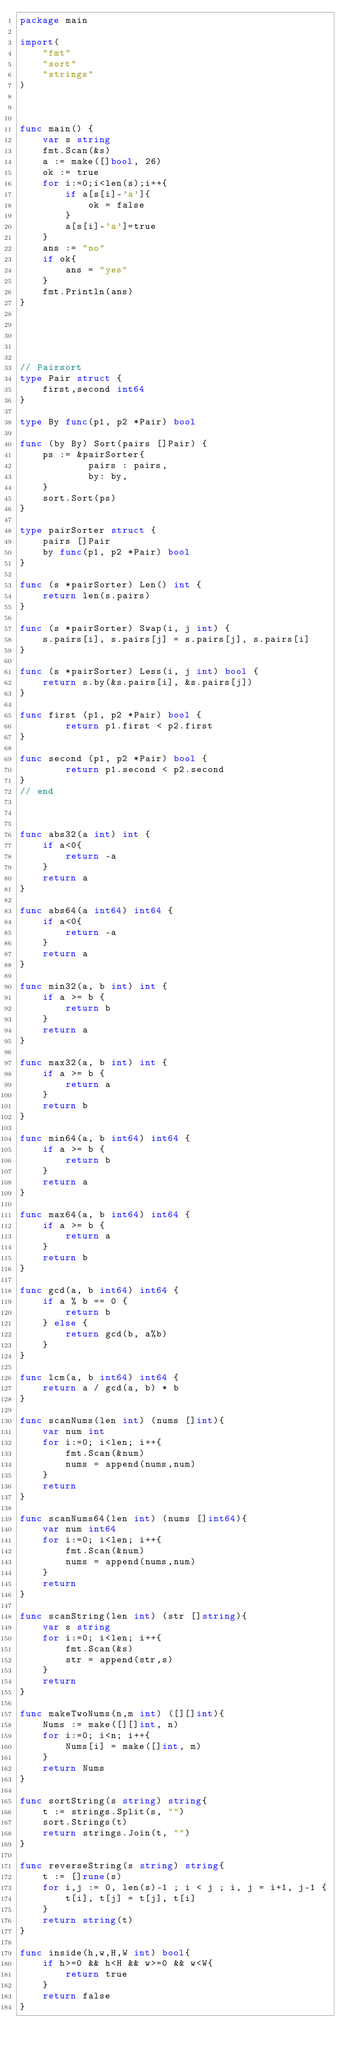<code> <loc_0><loc_0><loc_500><loc_500><_Go_>package main

import(
    "fmt"
    "sort"
    "strings"
)



func main() {
    var s string
    fmt.Scan(&s)
    a := make([]bool, 26)
    ok := true
    for i:=0;i<len(s);i++{
        if a[s[i]-'a']{
            ok = false
        }
        a[s[i]-'a']=true
    }
    ans := "no"
    if ok{
        ans = "yes"
    }
    fmt.Println(ans)
}





// Pairsort
type Pair struct {
    first,second int64
}

type By func(p1, p2 *Pair) bool

func (by By) Sort(pairs []Pair) {
    ps := &pairSorter{
            pairs : pairs,
            by: by,
    }
    sort.Sort(ps)
}

type pairSorter struct {
    pairs []Pair
    by func(p1, p2 *Pair) bool
}

func (s *pairSorter) Len() int {
    return len(s.pairs)
}

func (s *pairSorter) Swap(i, j int) {
    s.pairs[i], s.pairs[j] = s.pairs[j], s.pairs[i]
}

func (s *pairSorter) Less(i, j int) bool {
    return s.by(&s.pairs[i], &s.pairs[j])
}

func first (p1, p2 *Pair) bool {
        return p1.first < p2.first
}

func second (p1, p2 *Pair) bool {
        return p1.second < p2.second
}
// end



func abs32(a int) int {
    if a<0{
        return -a
    }
    return a
}

func abs64(a int64) int64 {
    if a<0{
        return -a
    }
    return a
}

func min32(a, b int) int {
    if a >= b {
        return b
    }
    return a
}

func max32(a, b int) int {
    if a >= b {
        return a
    }
    return b
}

func min64(a, b int64) int64 {
    if a >= b {
        return b
    }
    return a
}

func max64(a, b int64) int64 {
    if a >= b {
        return a
    }
    return b
}

func gcd(a, b int64) int64 {
    if a % b == 0 {
        return b
    } else {
        return gcd(b, a%b)
    }
}

func lcm(a, b int64) int64 {
    return a / gcd(a, b) * b
}

func scanNums(len int) (nums []int){
    var num int
    for i:=0; i<len; i++{
        fmt.Scan(&num)
        nums = append(nums,num)
    }
    return
}

func scanNums64(len int) (nums []int64){
    var num int64
    for i:=0; i<len; i++{
        fmt.Scan(&num)
        nums = append(nums,num)
    }
    return
}

func scanString(len int) (str []string){
    var s string
    for i:=0; i<len; i++{
        fmt.Scan(&s)
        str = append(str,s)
    }
    return
}

func makeTwoNums(n,m int) ([][]int){
    Nums := make([][]int, n)
    for i:=0; i<n; i++{
        Nums[i] = make([]int, m)
    }
    return Nums
}

func sortString(s string) string{
    t := strings.Split(s, "")
    sort.Strings(t)
    return strings.Join(t, "")
}

func reverseString(s string) string{
    t := []rune(s)
    for i,j := 0, len(s)-1 ; i < j ; i, j = i+1, j-1 {
        t[i], t[j] = t[j], t[i]
    }
    return string(t)
}

func inside(h,w,H,W int) bool{
    if h>=0 && h<H && w>=0 && w<W{
        return true
    }
    return false
}
</code> 